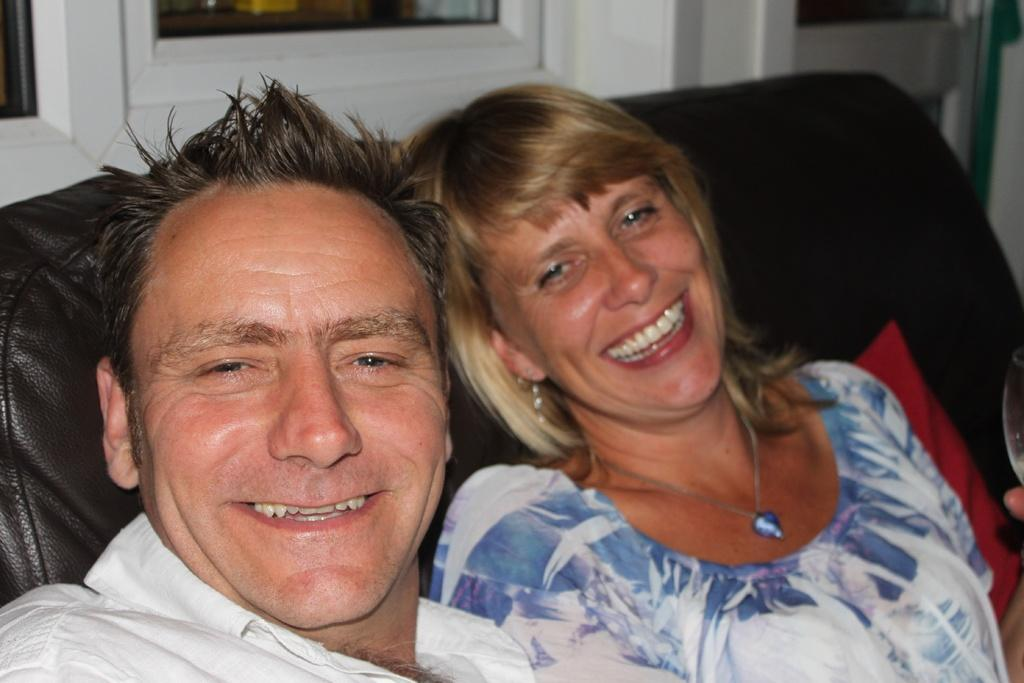How many people are present in the image? There are two people in the image. What are the two people doing in the image? The two people are sitting on a sofa. What can be seen in the background of the image? There are white-colored windows in the background of the image. What type of baseball game is being played in the image? There is no baseball game present in the image; it features two people sitting on a sofa with white-colored windows in the background. How does the carriage fit into the scene depicted in the image? There is no carriage present in the image; it only shows two people sitting on a sofa and white-colored windows in the background. 